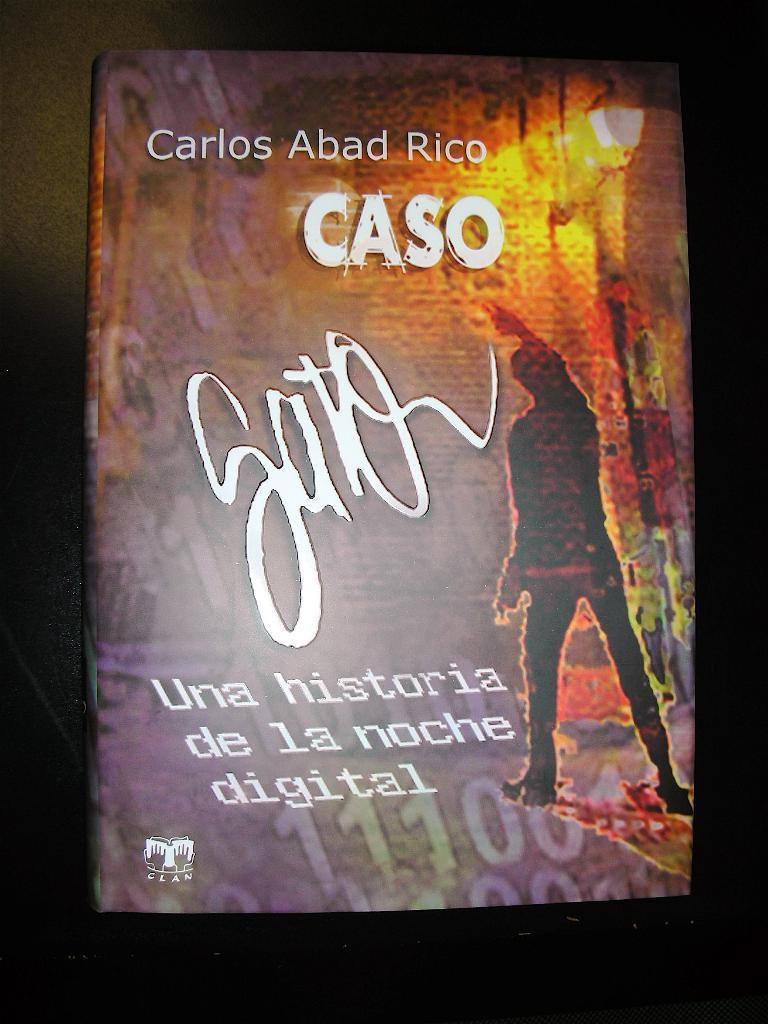<image>
Present a compact description of the photo's key features. A piece of artwork shoes a figure of a man and says, "Caso". 